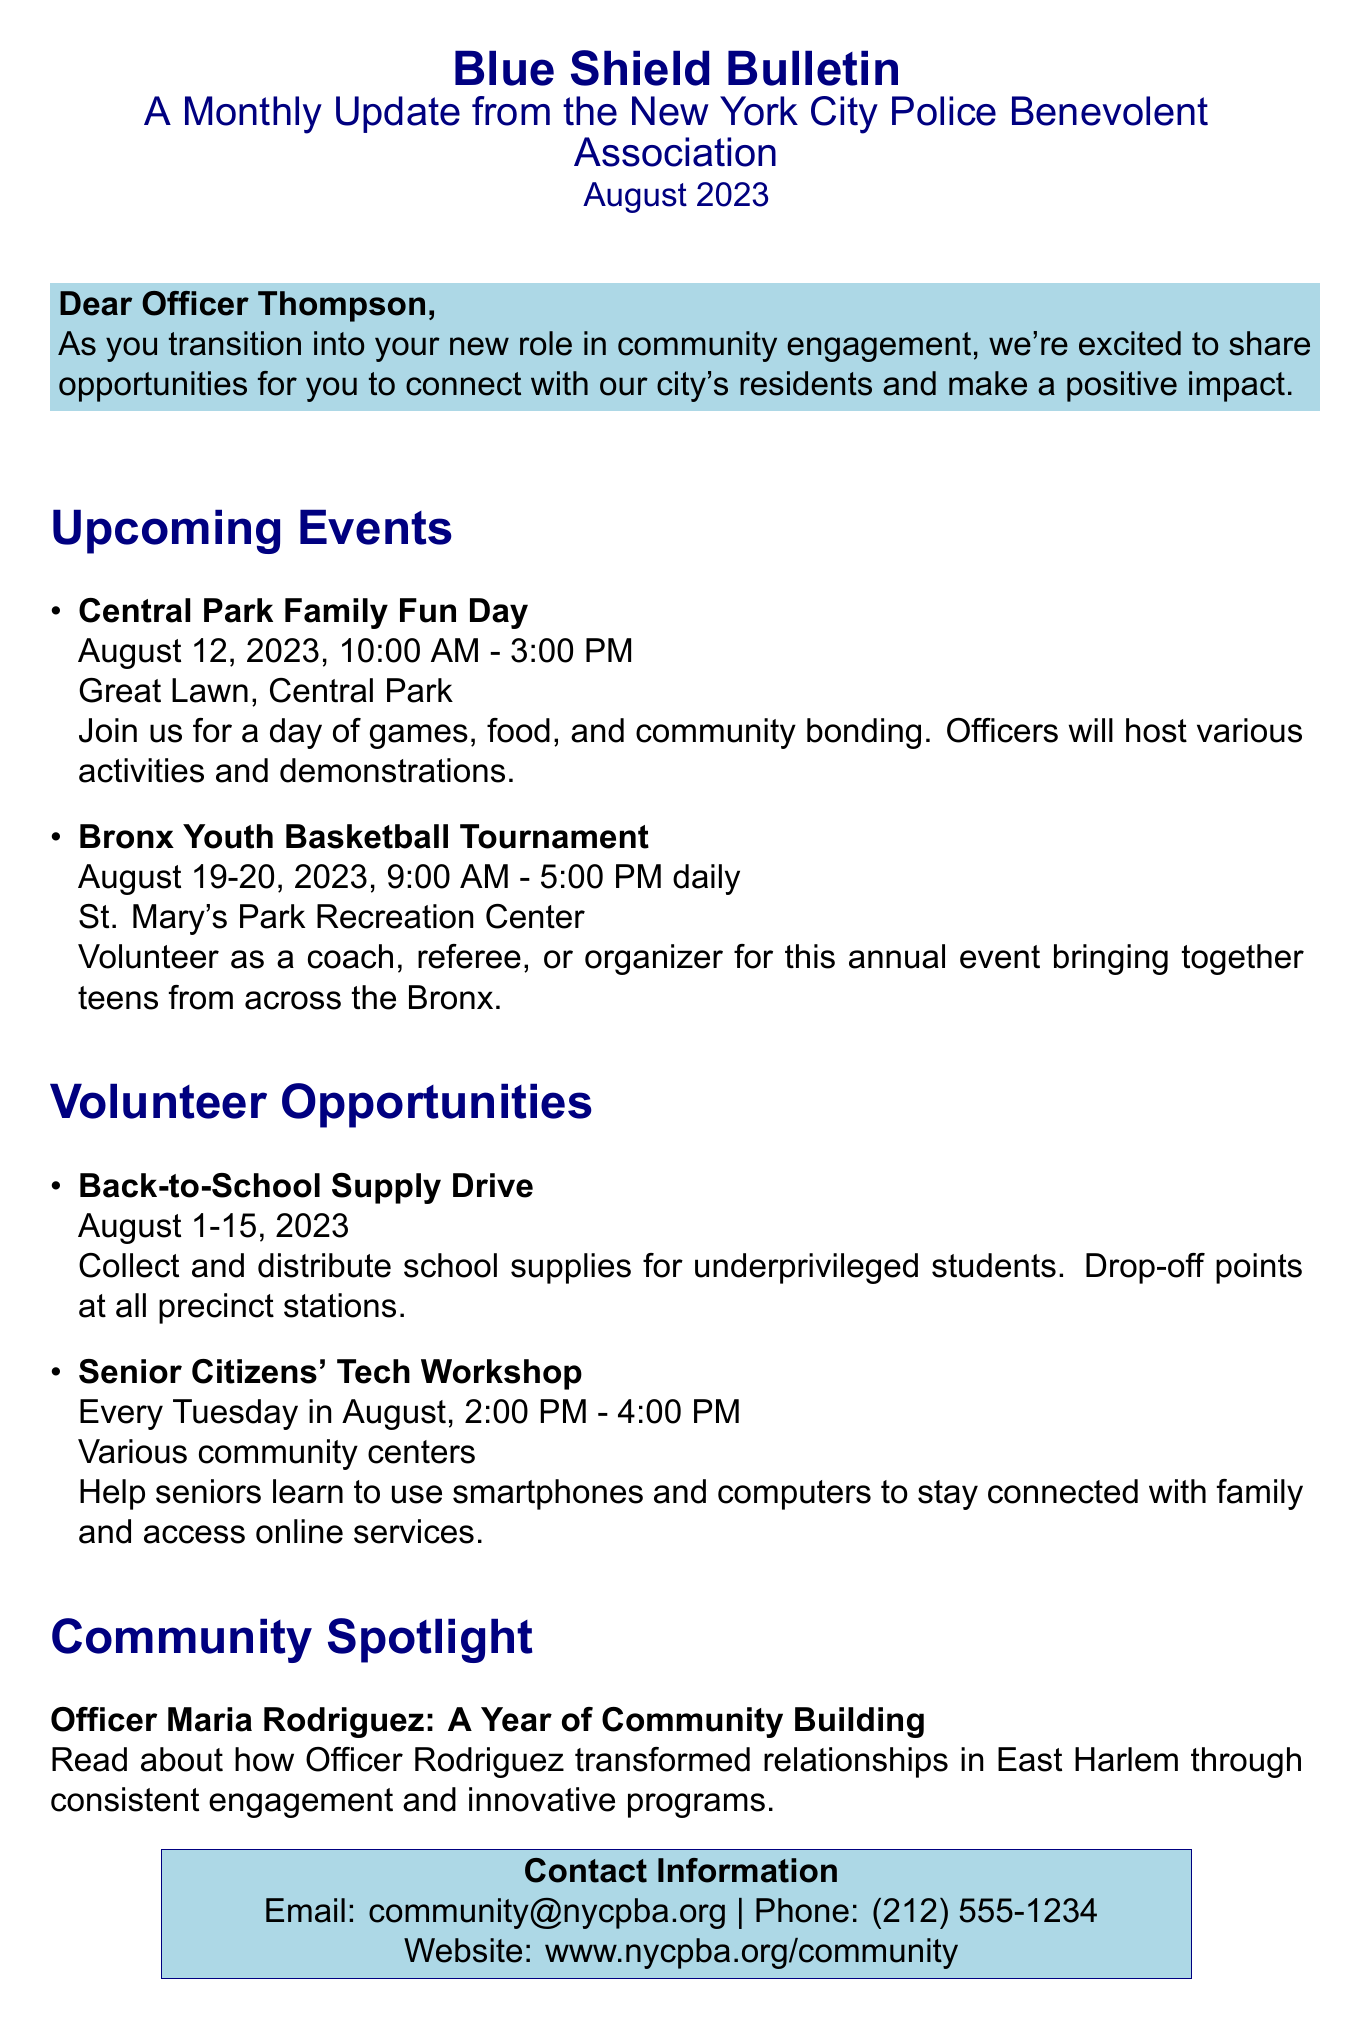What is the title of the newsletter? The title of the newsletter is found at the top of the document, which is the first piece of information given.
Answer: Blue Shield Bulletin What is the date of the Central Park Family Fun Day? The date can be found under the upcoming events section, specifically for the first event listed.
Answer: August 12, 2023 How long will the Senior Citizens' Tech Workshop last each Tuesday? The duration is specified in the description of the event, providing the end time in connection with the start time.
Answer: 2 hours Who is the community spotlight feature about? The community spotlight section provides a specific name of the officer being highlighted for her work in community building.
Answer: Officer Maria Rodriguez What is the email address for community contact? The email address can be located in the contact information section at the end of the document.
Answer: community@nycpba.org What location will host the Bronx Youth Basketball Tournament? The location is detailed in the information about the second upcoming event listed.
Answer: St. Mary's Park Recreation Center How many days is the Back-to-School Supply Drive held? The number of days can be inferred from the date range provided in the volunteer opportunities section of the document.
Answer: 15 days What day of the week does the Senior Citizens' Tech Workshop take place? The specific day is mentioned in the volunteer opportunities section describing the frequency of the event.
Answer: Tuesday How many upcoming events are listed in the newsletter? The number of upcoming events is indicated by how many entries are made under that specific section in the document.
Answer: 2 